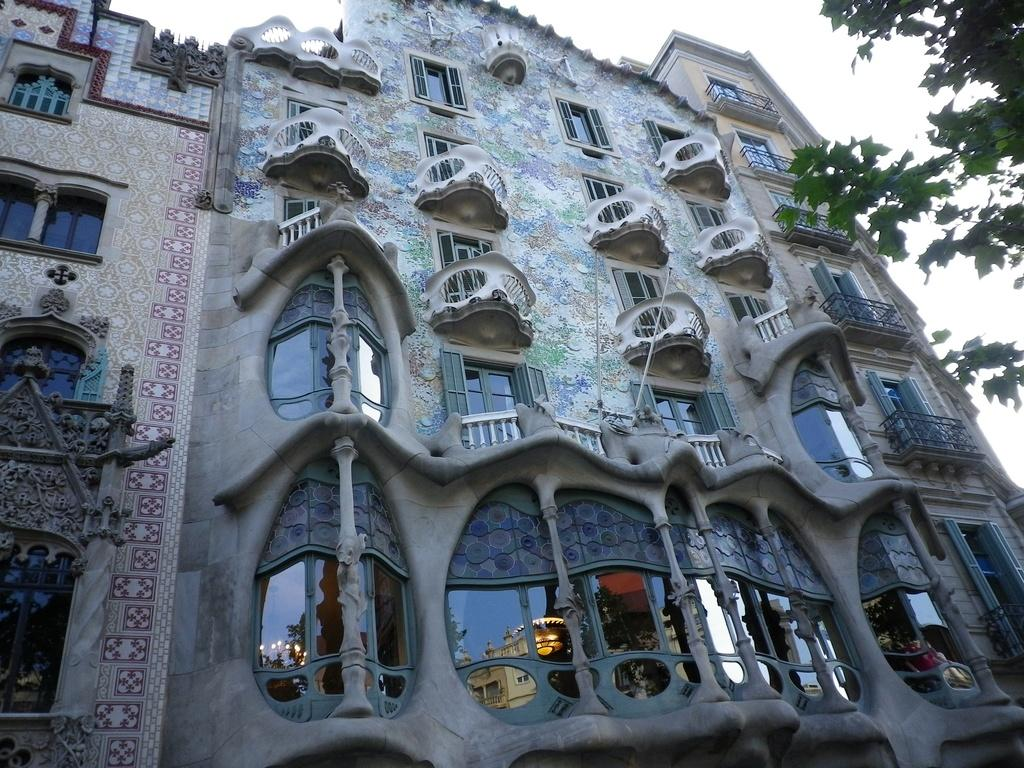What type of structure is in the image? There is a building in the image. What features can be seen on the building? The building has windows and doors. What is located on the right side of the image? There is a tree on the right side of the image. How would you describe the sky in the image? The sky is cloudy in the image. Can you hear the farmer talking to the sign in the image? There is no farmer or sign present in the image, so it is not possible to hear any conversation between them. 